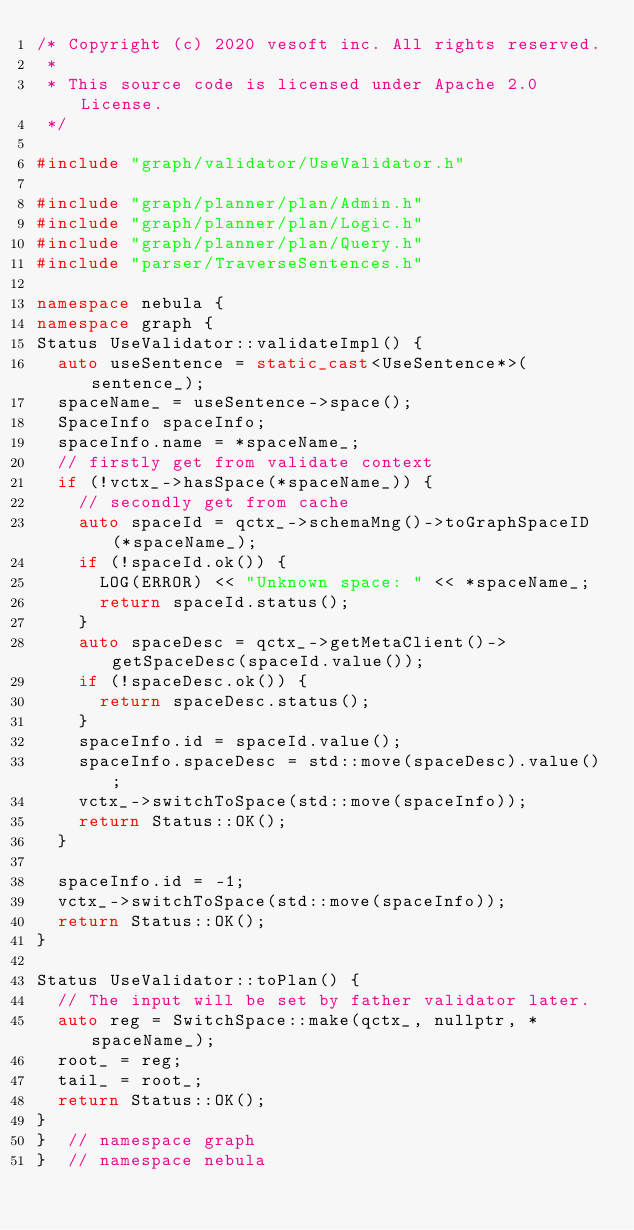Convert code to text. <code><loc_0><loc_0><loc_500><loc_500><_C++_>/* Copyright (c) 2020 vesoft inc. All rights reserved.
 *
 * This source code is licensed under Apache 2.0 License.
 */

#include "graph/validator/UseValidator.h"

#include "graph/planner/plan/Admin.h"
#include "graph/planner/plan/Logic.h"
#include "graph/planner/plan/Query.h"
#include "parser/TraverseSentences.h"

namespace nebula {
namespace graph {
Status UseValidator::validateImpl() {
  auto useSentence = static_cast<UseSentence*>(sentence_);
  spaceName_ = useSentence->space();
  SpaceInfo spaceInfo;
  spaceInfo.name = *spaceName_;
  // firstly get from validate context
  if (!vctx_->hasSpace(*spaceName_)) {
    // secondly get from cache
    auto spaceId = qctx_->schemaMng()->toGraphSpaceID(*spaceName_);
    if (!spaceId.ok()) {
      LOG(ERROR) << "Unknown space: " << *spaceName_;
      return spaceId.status();
    }
    auto spaceDesc = qctx_->getMetaClient()->getSpaceDesc(spaceId.value());
    if (!spaceDesc.ok()) {
      return spaceDesc.status();
    }
    spaceInfo.id = spaceId.value();
    spaceInfo.spaceDesc = std::move(spaceDesc).value();
    vctx_->switchToSpace(std::move(spaceInfo));
    return Status::OK();
  }

  spaceInfo.id = -1;
  vctx_->switchToSpace(std::move(spaceInfo));
  return Status::OK();
}

Status UseValidator::toPlan() {
  // The input will be set by father validator later.
  auto reg = SwitchSpace::make(qctx_, nullptr, *spaceName_);
  root_ = reg;
  tail_ = root_;
  return Status::OK();
}
}  // namespace graph
}  // namespace nebula
</code> 